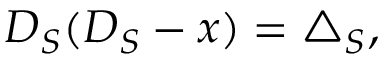<formula> <loc_0><loc_0><loc_500><loc_500>D _ { S } ( D _ { S } - x ) = \triangle _ { S } ,</formula> 